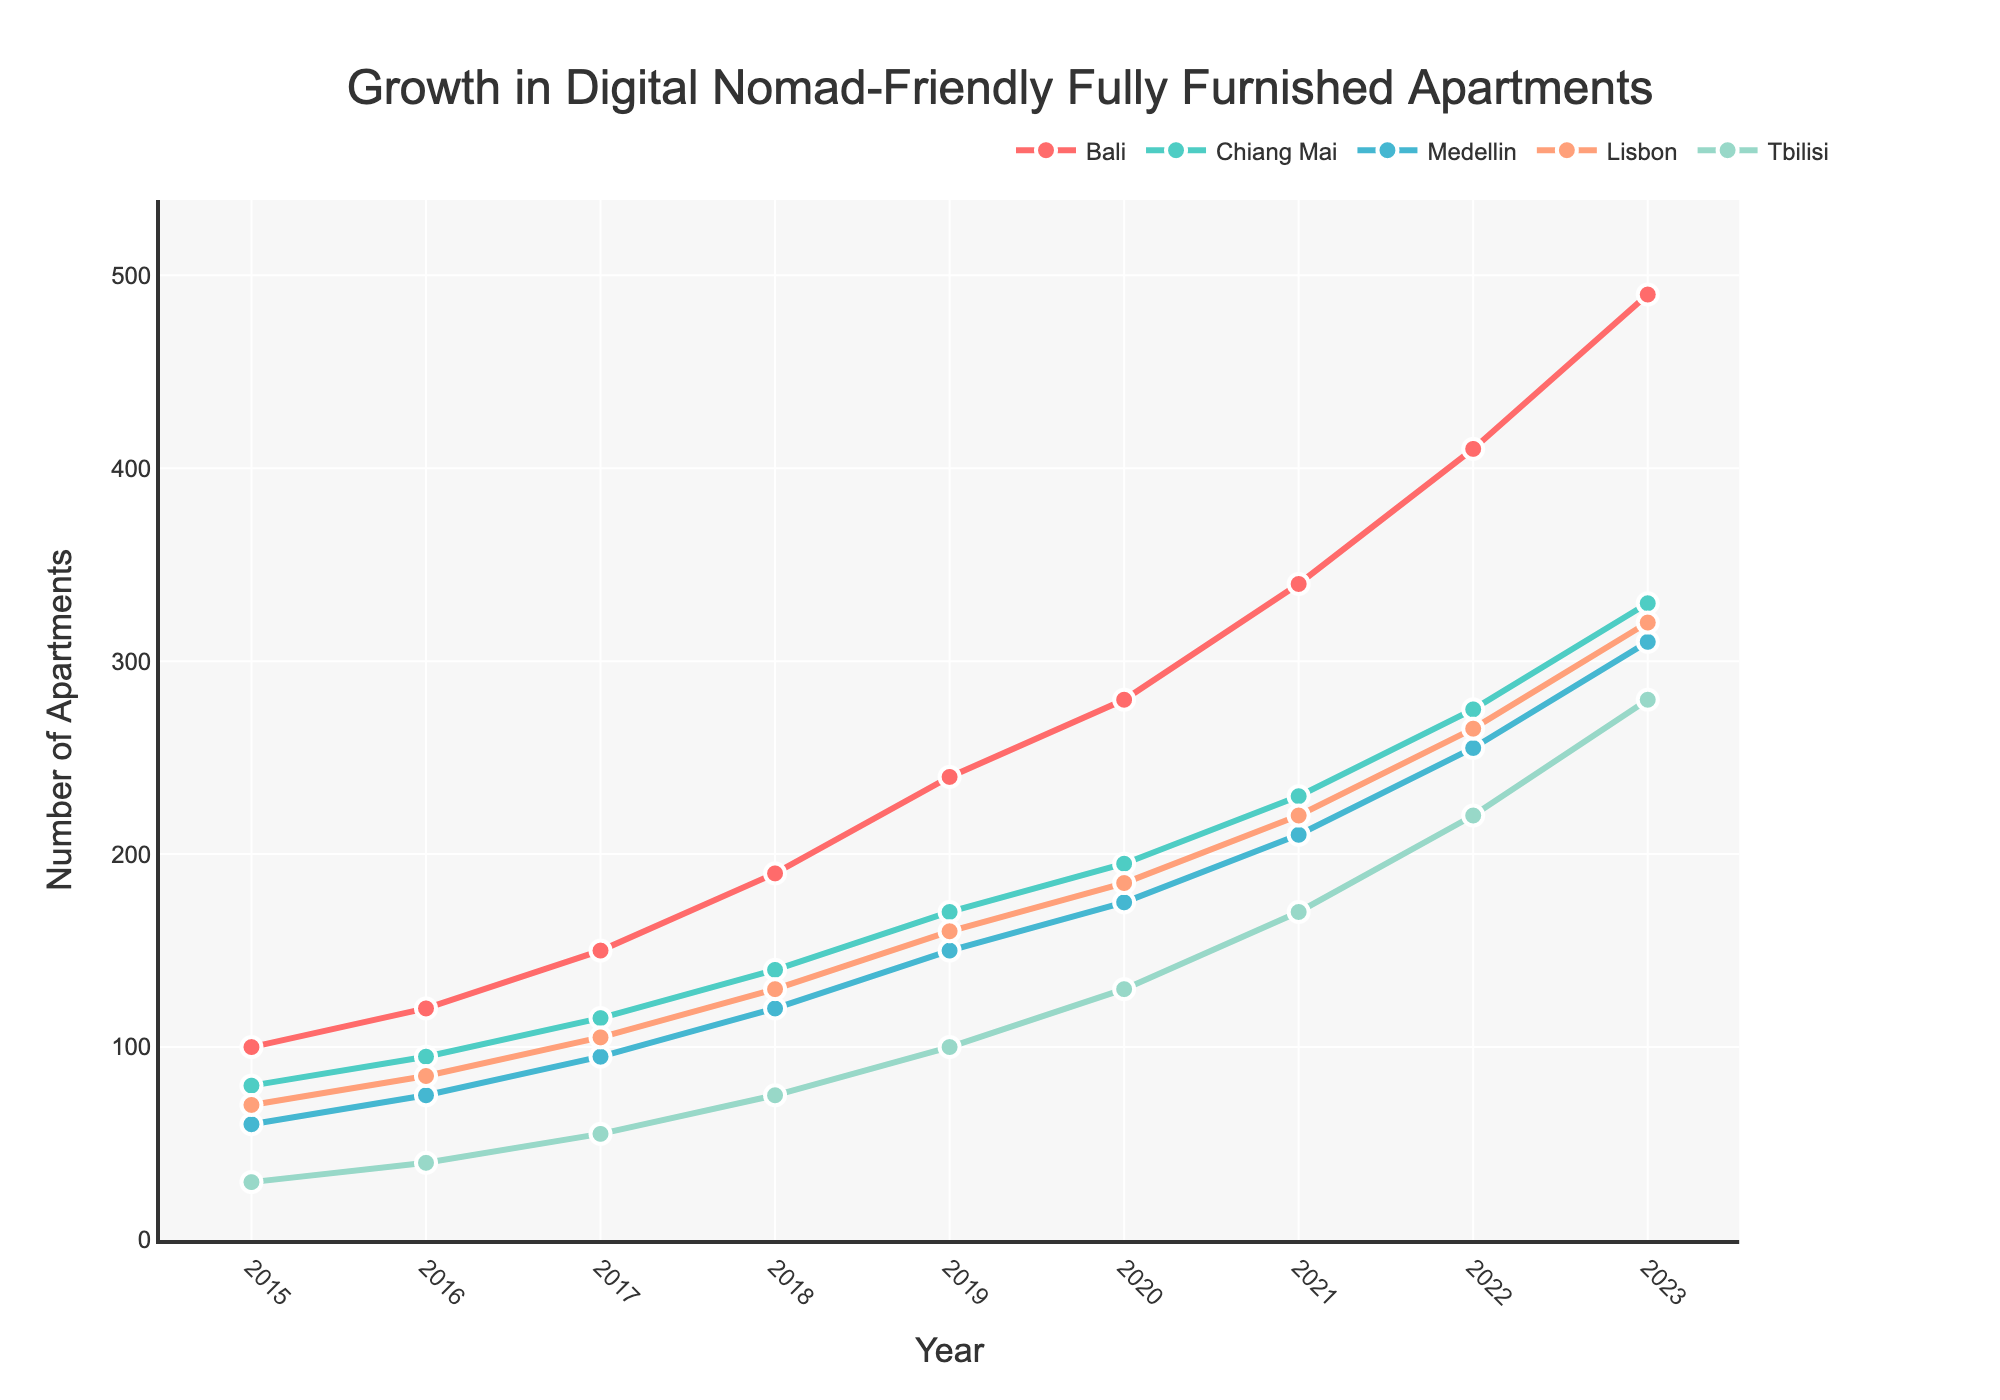What is the growth in the number of digital nomad-friendly fully furnished apartments in Bali from 2015 to 2023? To find the growth, subtract the number of apartments in 2015 from that in 2023. Bali had 100 apartments in 2015 and 490 in 2023. Therefore, the growth is 490 - 100 = 390.
Answer: 390 Which location had the highest number of digital nomad-friendly fully furnished apartments in 2023? Looking at the figure, Bali had the highest number of fully furnished apartments in 2023 with 490 apartments.
Answer: Bali How does the number of fully furnished apartments in Chiang Mai in 2018 compare to those in Medellin in 2015? Chiang Mai had 140 apartments in 2018, while Medellin had 60 apartments in 2015. To compare, 140 is greater than 60.
Answer: Chiang Mai (greater) Between which consecutive years did Tbilisi experience the highest growth in the number of fully furnished apartments? Tbilisi's apartment numbers grew as follows: 30 (2015), 40 (2016), 55 (2017), 75 (2018), 100 (2019), 130 (2020), 170 (2021), 220 (2022), 280 (2023). The highest growth between consecutive years is from 2021 to 2022, growing by 50 apartments (220 - 170 = 50).
Answer: 2021-2022 Calculate the average number of fully furnished apartments available in Lisbon across all the years shown. To find the average, sum the number of apartments in Lisbon from 2015 to 2023 and divide by the number of years: (70 + 85 + 105 + 130 + 160 + 185 + 220 + 265 + 320) / 9 = 1690 / 9 ≈ 187.8.
Answer: 187.8 For which location did the number of fully furnished apartments triple from 2015 to 2023? To triple, the number of apartments in 2023 must be three times the number in 2015. For Tbilisi, the numbers are 30 in 2015 and 280 in 2023. 280 is more than three times 30, indicating it is more than tripled. Other locations do not meet this criterion.
Answer: Tbilisi What is the total number of fully furnished apartments for all locations combined in 2020? Sum the number of apartments in all locations for 2020: 280 (Bali) + 195 (Chiang Mai) + 175 (Medellin) + 185 (Lisbon) + 130 (Tbilisi) = 965.
Answer: 965 Which location had the slowest growth rate in the number of fully furnished apartments between 2015 and 2023? To find the slowest growth rate, calculate the growth for each location from 2015 to 2023 and compare. Tbilisi had 30 in 2015 and 280 in 2023 (growth of 250), while others had higher growths. Thus, Tbilisi had the slowest growth rate.
Answer: Tbilisi 